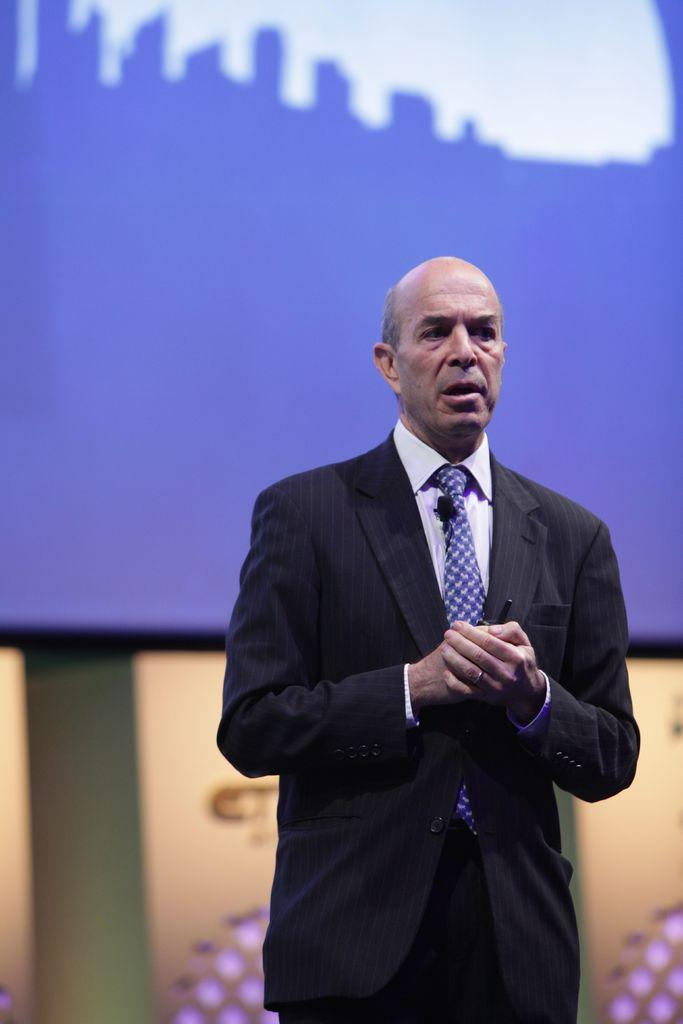What is the main subject of the image? The main subject of the image is a man. What is the man doing in the image? The man is standing in the image. What is the man wearing in the image? The man is wearing a suit, a white shirt, and a blue tie in the image. What is the man holding in his hand in the image? The man is holding a pen in his hand in the image. What can be seen behind the man in the image? There is a screen behind the man in the image. What type of furniture is causing trouble for the man in the image? There is no furniture present in the image, nor is there any indication of trouble for the man. 